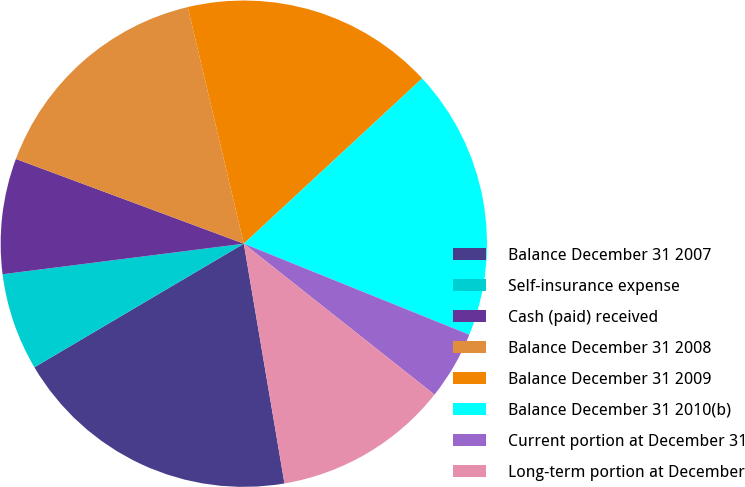<chart> <loc_0><loc_0><loc_500><loc_500><pie_chart><fcel>Balance December 31 2007<fcel>Self-insurance expense<fcel>Cash (paid) received<fcel>Balance December 31 2008<fcel>Balance December 31 2009<fcel>Balance December 31 2010(b)<fcel>Current portion at December 31<fcel>Long-term portion at December<nl><fcel>19.19%<fcel>6.48%<fcel>7.67%<fcel>15.63%<fcel>16.81%<fcel>18.0%<fcel>4.55%<fcel>11.67%<nl></chart> 